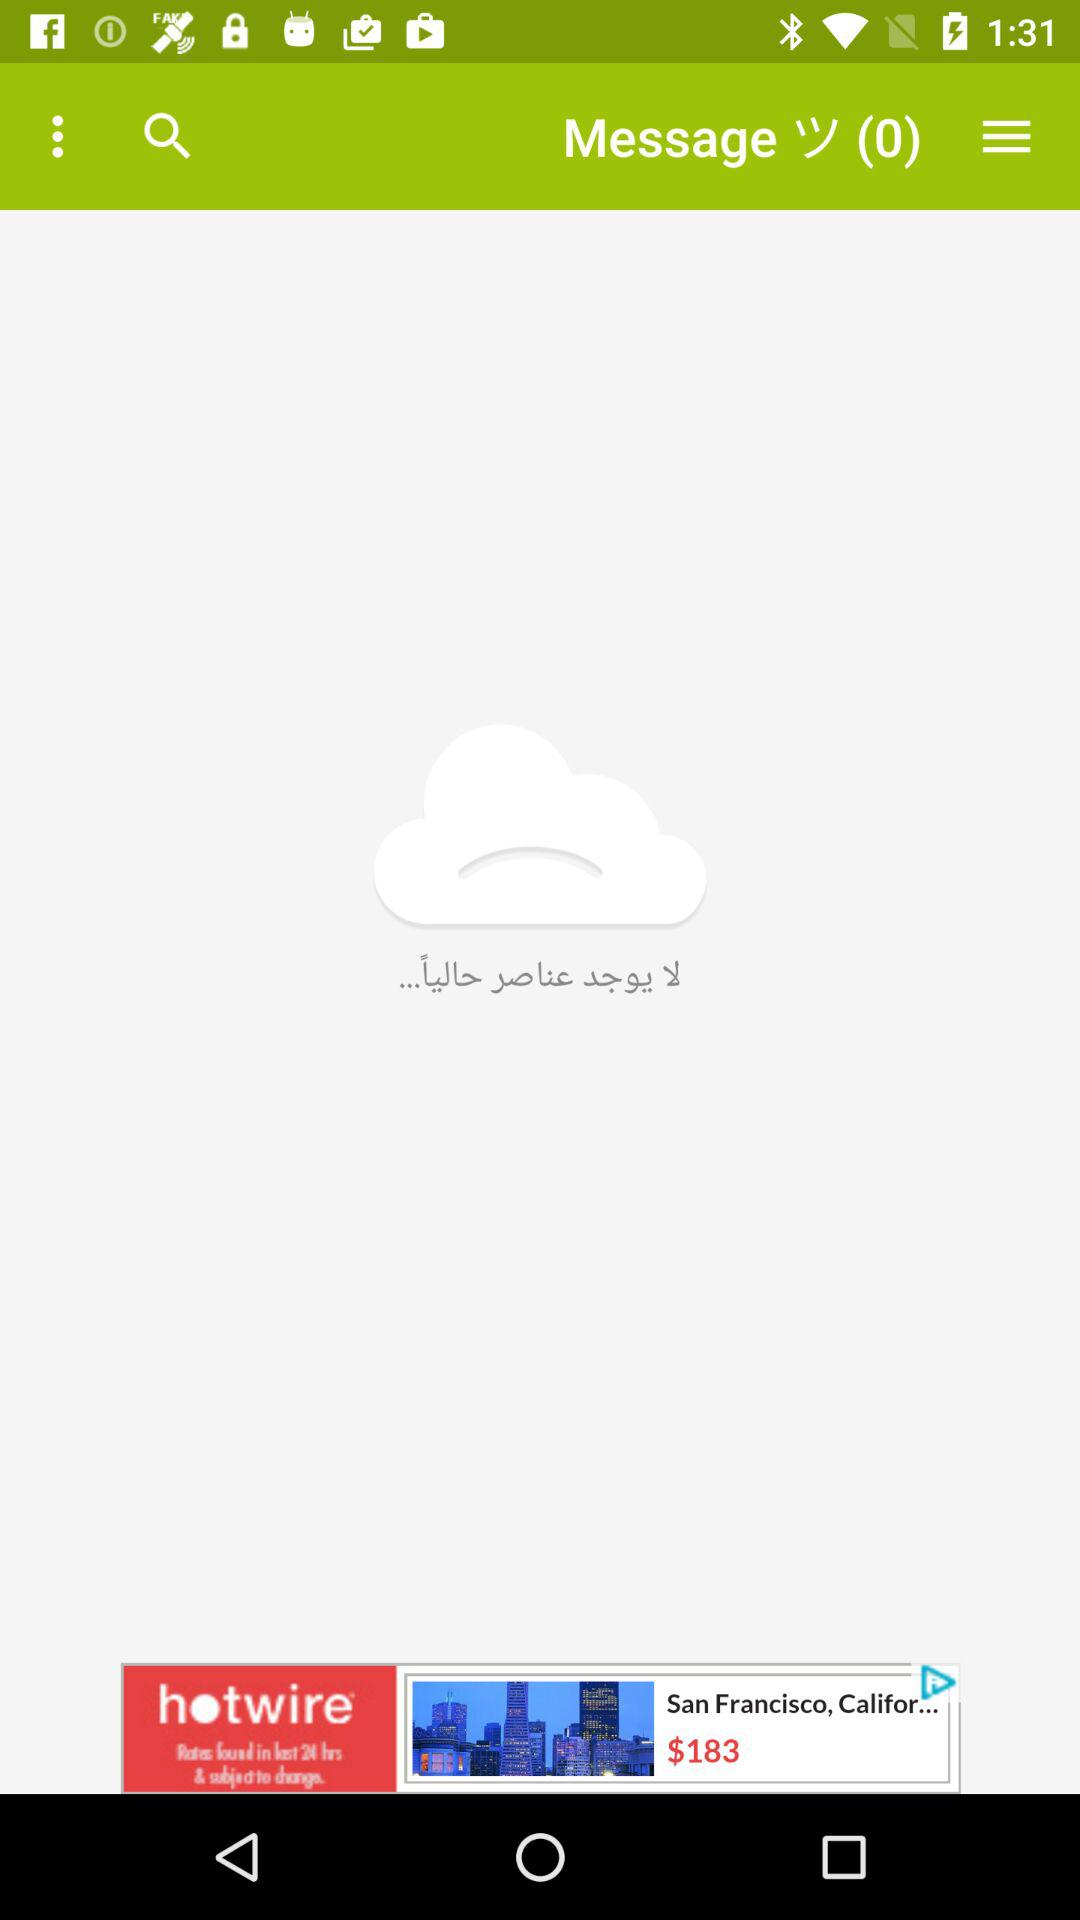How many messages are there? There are 0 messages. 